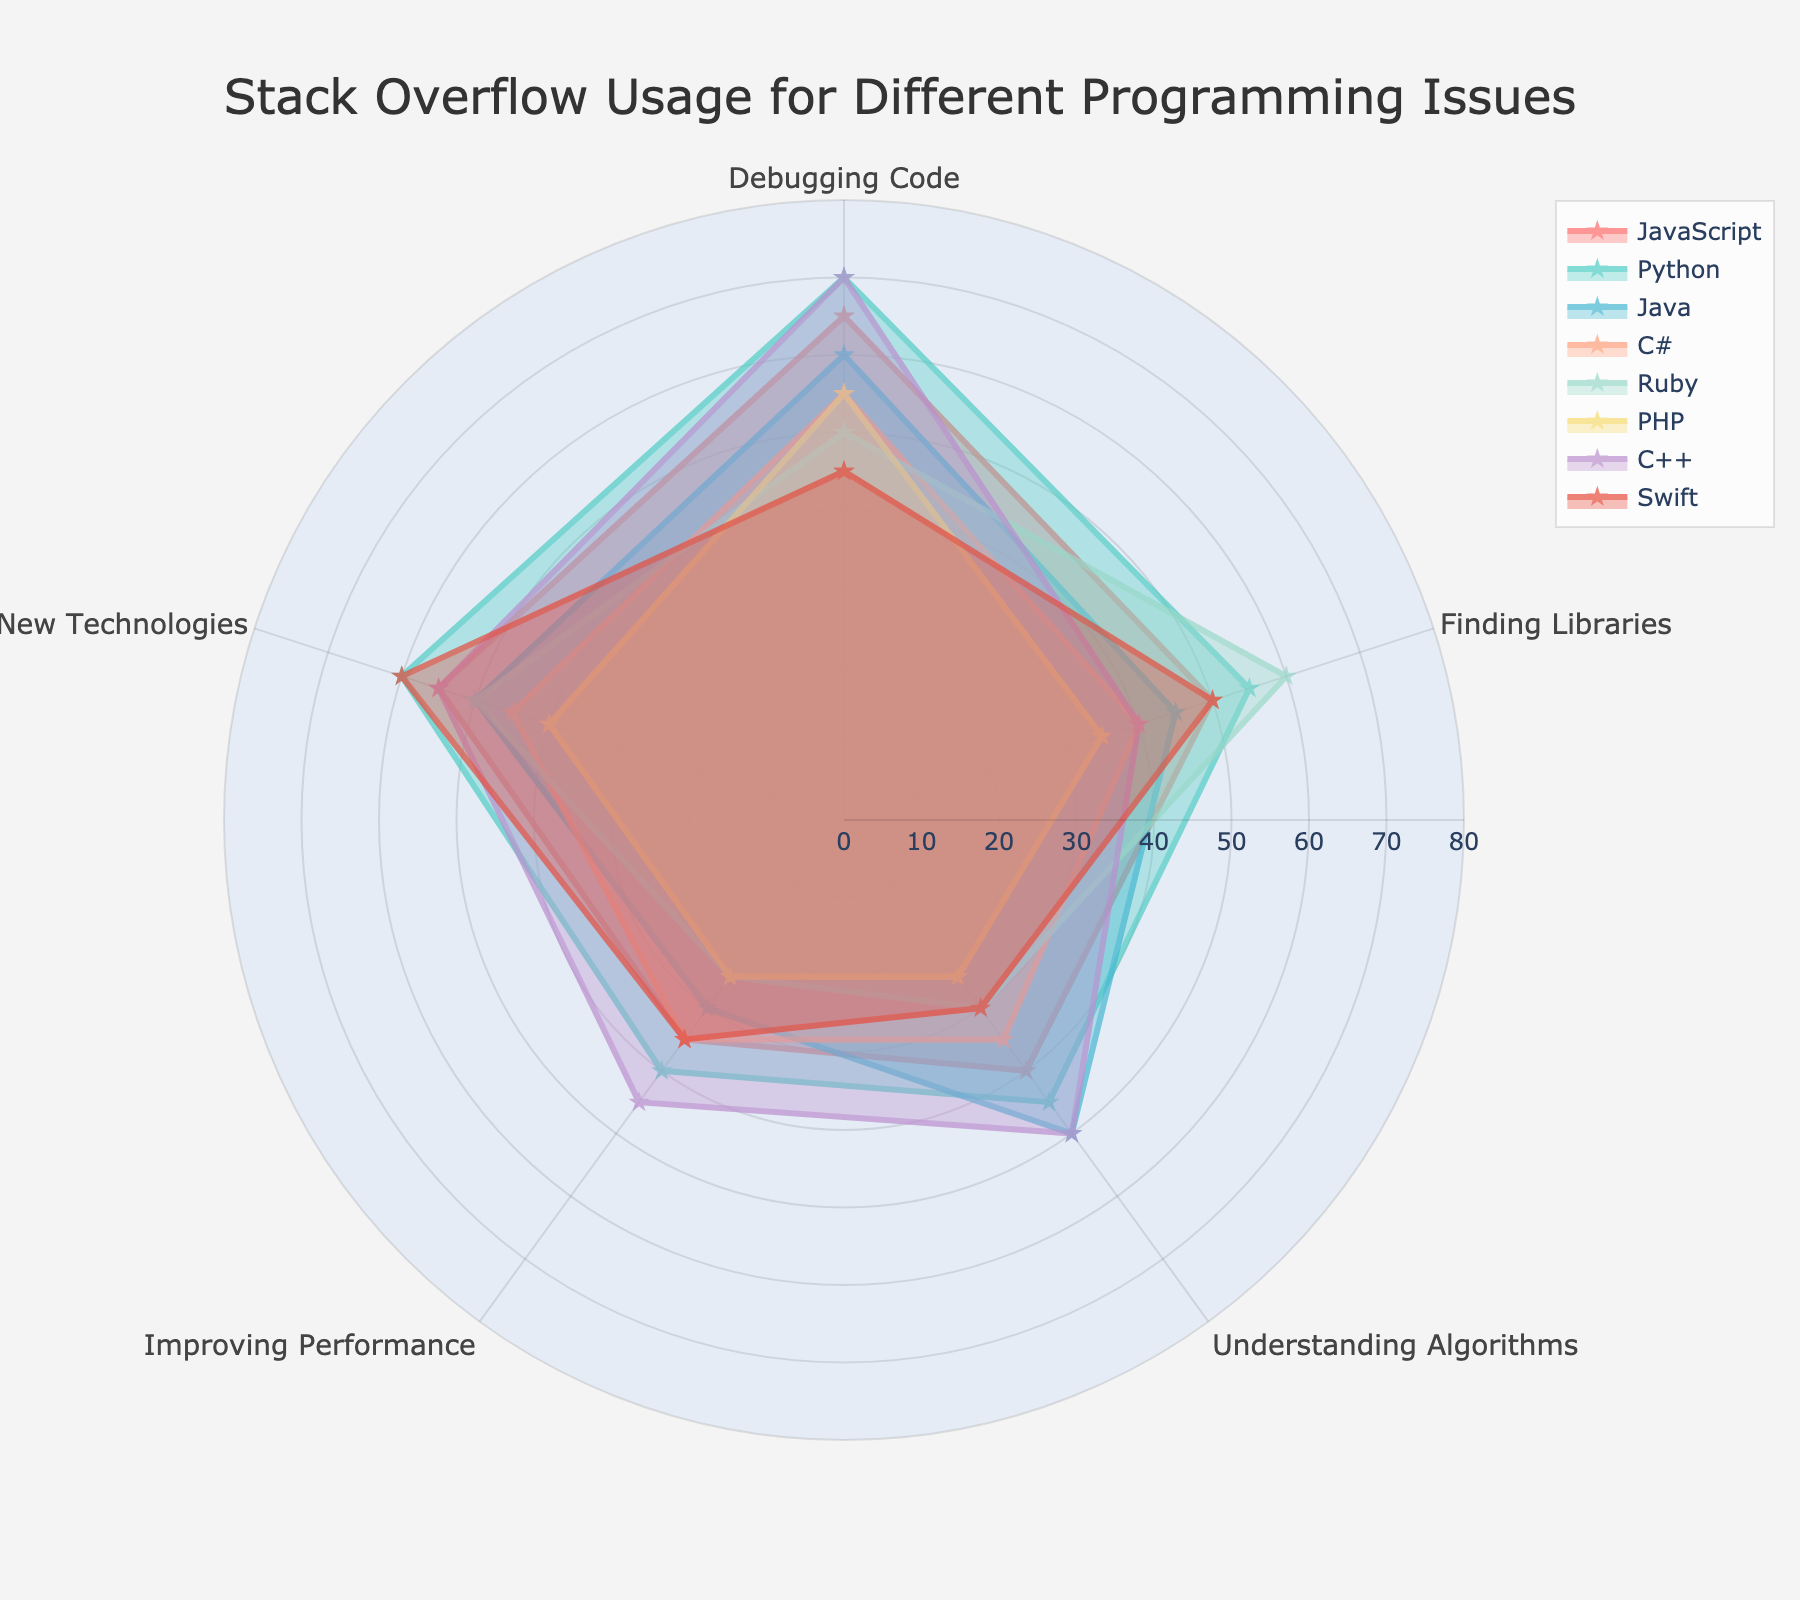what's the title of the radar chart? The title is usually displayed at the top of the chart, which indicates the main subject or purpose of the visualization.
Answer: Stack Overflow Usage for Different Programming Issues how many programming languages are compared in the radar chart? By counting the number of different lines or labels in the legend, you can determine the total number of programming languages. There are labels for JavaScript, Python, Java, C#, Ruby, PHP, C++, and Swift.
Answer: 8 which programming language has the highest value for "Learning New Technologies"? Look at the "Learning New Technologies" section for each programming language and compare the values. Swift has the highest value.
Answer: Swift which issue is the most frequent reason for C++ developers to use Stack Overflow? By examining the values for C++ in each category, the largest value indicates the most frequent issue being addressed. For C++, it's "Debugging Code."
Answer: Debugging Code what's the sum of the values for JavaScript in all categories? Add up all the values for JavaScript: 65 (Debugging Code) + 50 (Finding Libraries) + 40 (Understanding Algorithms) + 35 (Improving Performance) + 55 (Learning New Technologies). The total sum is 245.
Answer: 245 which category shows the least variation in usage frequency among all programming languages? By visually comparing the spread of values for each category, the category with the smallest spread has the least variation. "Improving Performance" seems to have the least variation.
Answer: Improving Performance how does the usage frequency for "Finding Libraries" compare between Ruby and C#? Compare the values for "Finding Libraries" category for Ruby and C#. Ruby has a value of 60, while C# has a value of 40. Therefore, Ruby has a higher usage frequency for finding libraries.
Answer: Ruby is higher what's the average value for Python across all programming issues? Sum up the values for Python across all categories: 70 + 55 + 45 + 40 + 60, then divide this sum by the total number of categories (5). The sum is 270, so the average is 270/5.
Answer: 54 which two languages have the most similar usage frequency profiles? By closely observing the plot and the shape of the radar chart, compare the profiles of the languages. Ruby and JavaScript have similar usage profiles.
Answer: Ruby and JavaScript what is the maximum value represented in this radar chart? Look for the highest point on the radar chart across all categories and languages. The highest value is 70, seen in multiple instances like Python and C++ for "Debugging Code."
Answer: 70 